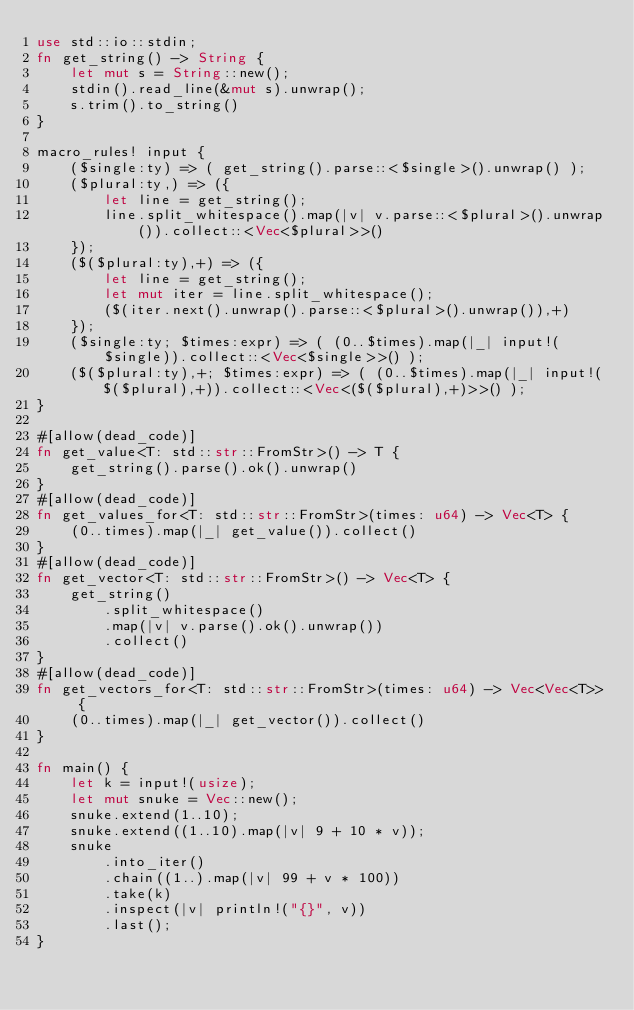<code> <loc_0><loc_0><loc_500><loc_500><_Rust_>use std::io::stdin;
fn get_string() -> String {
    let mut s = String::new();
    stdin().read_line(&mut s).unwrap();
    s.trim().to_string()
}

macro_rules! input {
    ($single:ty) => ( get_string().parse::<$single>().unwrap() );
    ($plural:ty,) => ({
        let line = get_string();
        line.split_whitespace().map(|v| v.parse::<$plural>().unwrap()).collect::<Vec<$plural>>()
    });
    ($($plural:ty),+) => ({
        let line = get_string();
        let mut iter = line.split_whitespace();
        ($(iter.next().unwrap().parse::<$plural>().unwrap()),+)
    });
    ($single:ty; $times:expr) => ( (0..$times).map(|_| input!($single)).collect::<Vec<$single>>() );
    ($($plural:ty),+; $times:expr) => ( (0..$times).map(|_| input!($($plural),+)).collect::<Vec<($($plural),+)>>() );
}

#[allow(dead_code)]
fn get_value<T: std::str::FromStr>() -> T {
    get_string().parse().ok().unwrap()
}
#[allow(dead_code)]
fn get_values_for<T: std::str::FromStr>(times: u64) -> Vec<T> {
    (0..times).map(|_| get_value()).collect()
}
#[allow(dead_code)]
fn get_vector<T: std::str::FromStr>() -> Vec<T> {
    get_string()
        .split_whitespace()
        .map(|v| v.parse().ok().unwrap())
        .collect()
}
#[allow(dead_code)]
fn get_vectors_for<T: std::str::FromStr>(times: u64) -> Vec<Vec<T>> {
    (0..times).map(|_| get_vector()).collect()
}

fn main() {
    let k = input!(usize);
    let mut snuke = Vec::new();
    snuke.extend(1..10);
    snuke.extend((1..10).map(|v| 9 + 10 * v));
    snuke
        .into_iter()
        .chain((1..).map(|v| 99 + v * 100))
        .take(k)
        .inspect(|v| println!("{}", v))
        .last();
}
</code> 